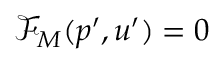Convert formula to latex. <formula><loc_0><loc_0><loc_500><loc_500>\mathcal { F } _ { M } ( p ^ { \prime } , u ^ { \prime } ) = 0</formula> 